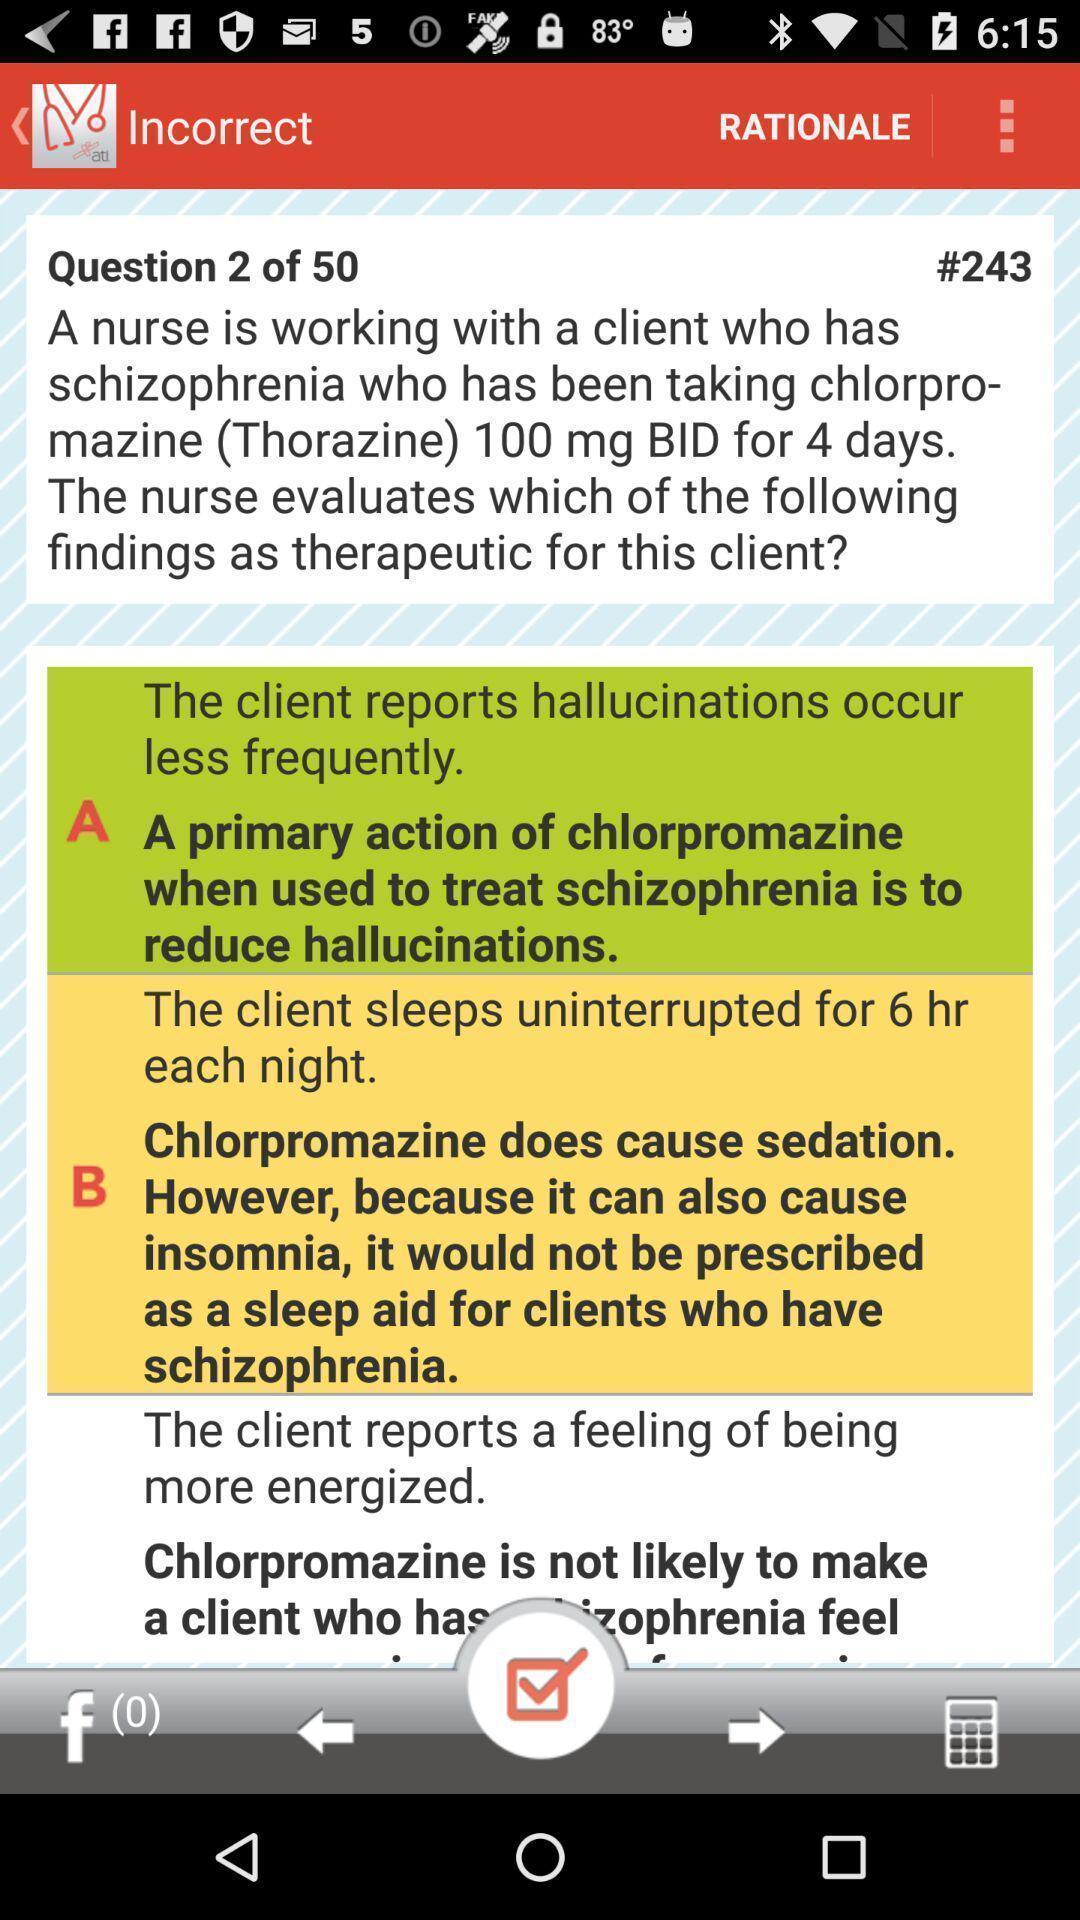What can you discern from this picture? Various kinds of questions and answers in the application. 